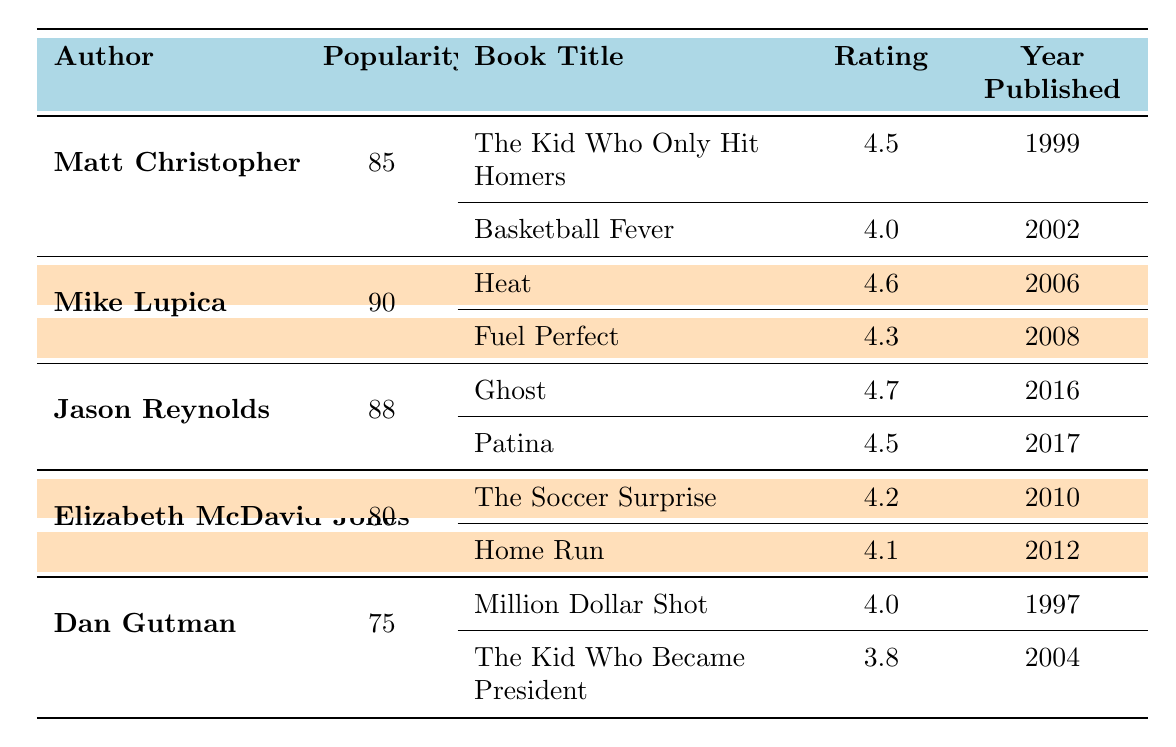What is the average rating of Matt Christopher's books? To find the average rating, first sum the ratings of Matt Christopher's books: 4.5 + 4.0 = 8.5. There are 2 books, so the average rating is 8.5 / 2 = 4.25.
Answer: 4.25 Which author has the highest popularity? Looking at the Popularity column, Mike Lupica has the highest value at 90.
Answer: Mike Lupica Is Jason Reynolds' book "Ghost" rated higher than "Fuel Perfect"? Comparing the ratings, "Ghost" has a rating of 4.7 and "Fuel Perfect" has a rating of 4.3. Since 4.7 is greater than 4.3, the statement is true.
Answer: Yes What is the total number of books published by Elizabeth McDavid Jones? Elizabeth McDavid Jones has 2 books listed: "The Soccer Surprise" and "Home Run". Therefore, the total number of books is 2.
Answer: 2 How many books have a rating of 4.5 or above? The books with a rating of 4.5 or above are: "The Kid Who Only Hit Homers" (4.5), "Heat" (4.6), "Ghost" (4.7), "Patina" (4.5), and "The Soccer Surprise" (4.2). Counting these, there are 4 books.
Answer: 4 Did Dan Gutman publish a book rated above 4.0? Looking at Dan Gutman's books, "Million Dollar Shot" is rated 4.0 and "The Kid Who Became President" is rated 3.8. Neither book is rated above 4.0, so the statement is false.
Answer: No What are the publication years of the books by Mike Lupica? The publication years for Mike Lupica's books are: "Heat" (2006) and "Fuel Perfect" (2008). So, the years are 2006 and 2008.
Answer: 2006, 2008 Which author's average book rating is the highest? First, we calculate the average ratings: Matt Christopher (4.25), Mike Lupica (4.45), Jason Reynolds (4.6), Elizabeth McDavid Jones (4.15), and Dan Gutman (3.9). The highest average rating is for Jason Reynolds at 4.6.
Answer: Jason Reynolds 